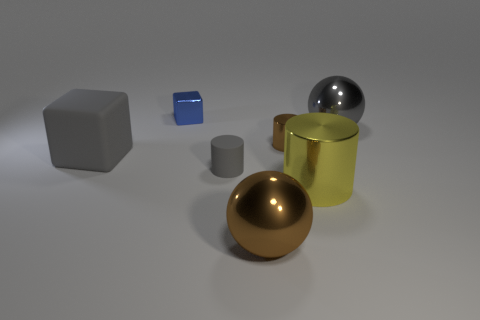There is a gray object in front of the large gray object that is in front of the gray shiny sphere; what is it made of?
Give a very brief answer. Rubber. There is a big thing that is left of the small gray thing; what is it made of?
Provide a short and direct response. Rubber. How many yellow shiny objects are the same shape as the small brown shiny thing?
Your answer should be compact. 1. Does the large matte cube have the same color as the rubber cylinder?
Offer a very short reply. Yes. What is the material of the cube that is to the left of the metal object behind the big sphere that is to the right of the big cylinder?
Keep it short and to the point. Rubber. Are there any cylinders behind the big gray cube?
Make the answer very short. Yes. There is a brown thing that is the same size as the yellow metal thing; what is its shape?
Provide a succinct answer. Sphere. Is the material of the tiny blue cube the same as the gray ball?
Offer a terse response. Yes. What number of matte things are either cylinders or big brown things?
Your answer should be compact. 1. What is the shape of the tiny matte object that is the same color as the rubber cube?
Keep it short and to the point. Cylinder. 